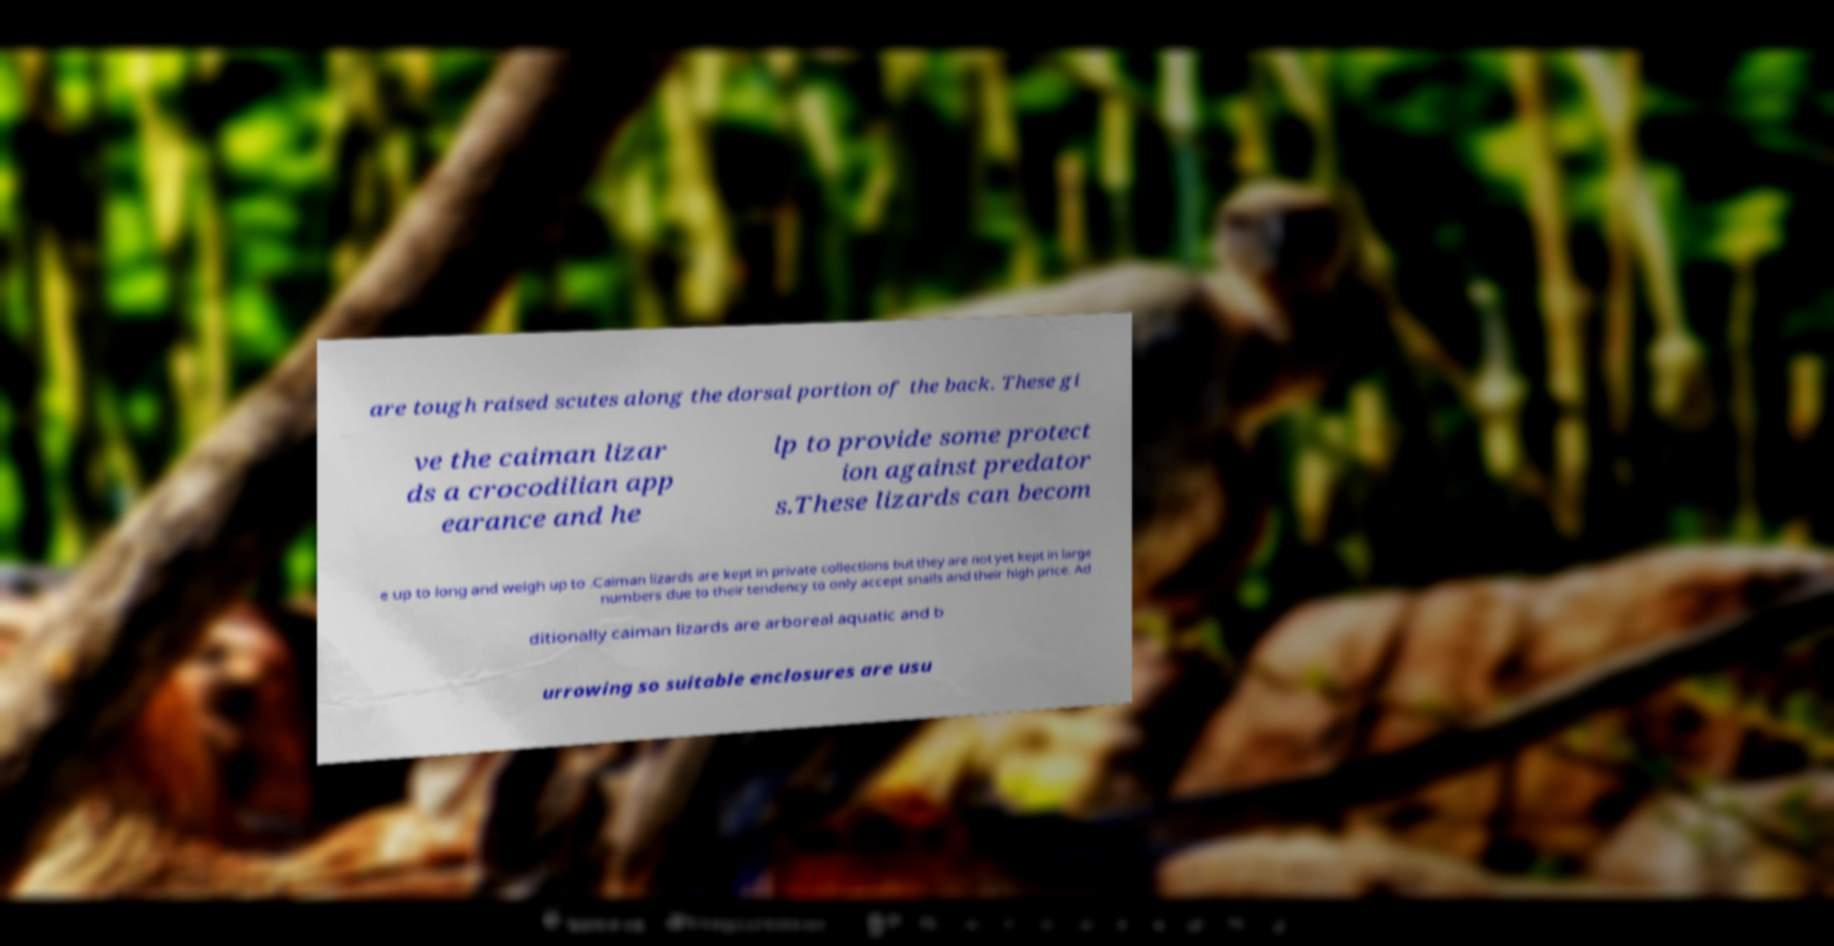Could you assist in decoding the text presented in this image and type it out clearly? are tough raised scutes along the dorsal portion of the back. These gi ve the caiman lizar ds a crocodilian app earance and he lp to provide some protect ion against predator s.These lizards can becom e up to long and weigh up to .Caiman lizards are kept in private collections but they are not yet kept in large numbers due to their tendency to only accept snails and their high price. Ad ditionally caiman lizards are arboreal aquatic and b urrowing so suitable enclosures are usu 